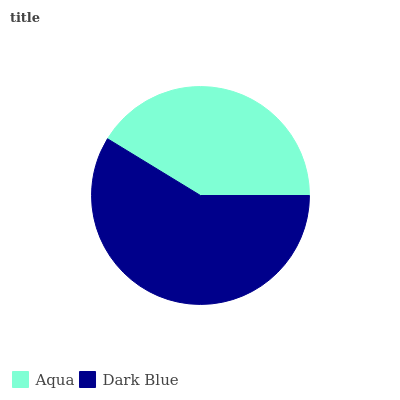Is Aqua the minimum?
Answer yes or no. Yes. Is Dark Blue the maximum?
Answer yes or no. Yes. Is Dark Blue the minimum?
Answer yes or no. No. Is Dark Blue greater than Aqua?
Answer yes or no. Yes. Is Aqua less than Dark Blue?
Answer yes or no. Yes. Is Aqua greater than Dark Blue?
Answer yes or no. No. Is Dark Blue less than Aqua?
Answer yes or no. No. Is Dark Blue the high median?
Answer yes or no. Yes. Is Aqua the low median?
Answer yes or no. Yes. Is Aqua the high median?
Answer yes or no. No. Is Dark Blue the low median?
Answer yes or no. No. 